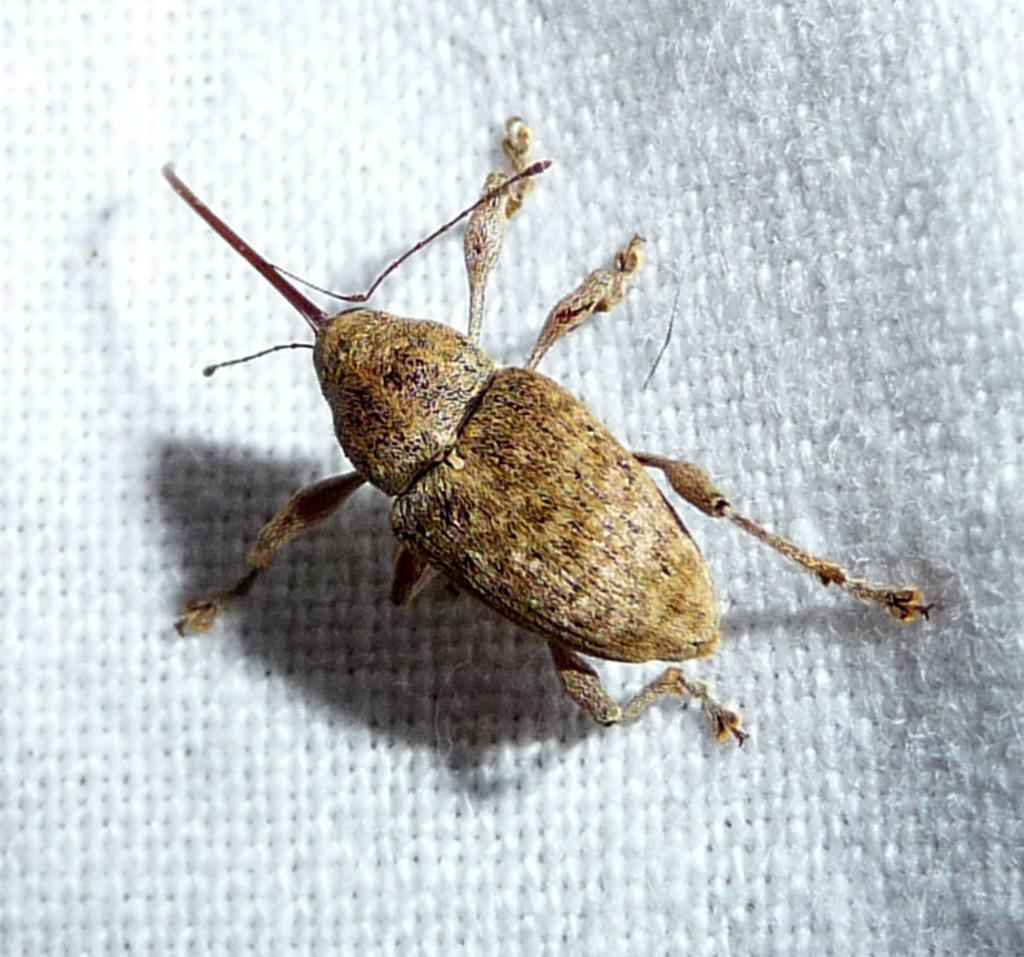What is the main subject of the image? The main subject of the image is a cockroach. What is the cockroach resting on in the image? The cockroach is on a white color cloth. How many rats are visible in the image? There are no rats present in the image; it only features a cockroach. What level of the building is the cockroach located on in the image? The image does not provide any information about the level or location of the cockroach within a building. 